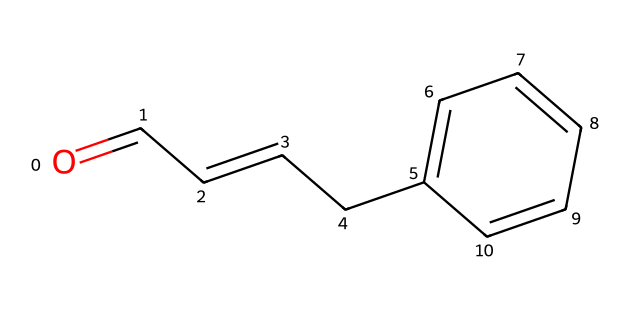What is the molecular formula of cinnamaldehyde? By examining the SMILES representation, we can count the carbon (C), hydrogen (H), and oxygen (O) atoms. The structure suggests there are 9 carbons, 8 hydrogens, and 1 oxygen, leading to the molecular formula C9H8O.
Answer: C9H8O How many double bonds are present in cinnamaldehyde? In the SMILES notation, we identify the presence of double bonds. The connection "C=C" shows one double bond between two carbon atoms, and the "C=O" represents a carbon-oxygen double bond, totaling two double bonds.
Answer: 2 What type of compound is cinnamaldehyde? Cinnamaldehyde has a distinct aldehyde functional group (indicated by the presence of the carbonyl group "C=O" at the end of the chain). It is characterized by its aromatic ring and aldehyde functionality, making it a flavor compound.
Answer: flavor compound What is the primary aroma characteristic of cinnamaldehyde? The aromatic component indicated by the benzene ring (in the structure) suggests that cinnamaldehyde has a strong and distinctive aromatic and spicy scent, closely associated with cinnamon.
Answer: spicy scent How does the structure of cinnamaldehyde relate to its flavor profile? Analyzing the structure, the aromatic ring and the aldehyde functional group contribute to its flavor. The aromaticity from the benzene ring gives complexity, while the carbonyl group provides sweetness, combining for a warm, sweet flavor associated with cinnamon.
Answer: warm, sweet flavor 